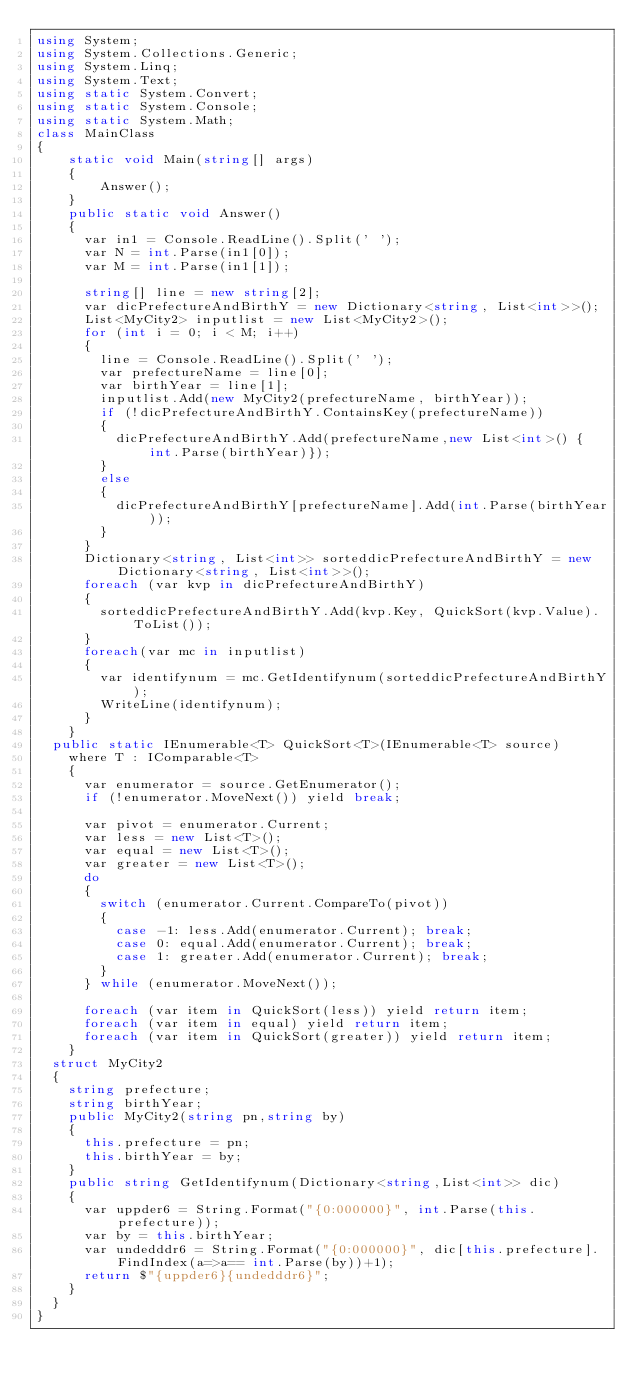Convert code to text. <code><loc_0><loc_0><loc_500><loc_500><_C#_>using System;
using System.Collections.Generic;
using System.Linq;
using System.Text;
using static System.Convert;
using static System.Console;
using static System.Math;
class MainClass
{
	static void Main(string[] args)
	{
		Answer();
	}
	public static void Answer()
	{
	  var in1 = Console.ReadLine().Split(' ');
      var N = int.Parse(in1[0]);
      var M = int.Parse(in1[1]);

      string[] line = new string[2];
      var dicPrefectureAndBirthY = new Dictionary<string, List<int>>();
      List<MyCity2> inputlist = new List<MyCity2>();
      for (int i = 0; i < M; i++)
      {
        line = Console.ReadLine().Split(' ');
        var prefectureName = line[0];
        var birthYear = line[1];
        inputlist.Add(new MyCity2(prefectureName, birthYear));
        if (!dicPrefectureAndBirthY.ContainsKey(prefectureName))
        {
          dicPrefectureAndBirthY.Add(prefectureName,new List<int>() { int.Parse(birthYear)});
        }
        else
        {
          dicPrefectureAndBirthY[prefectureName].Add(int.Parse(birthYear));
        }
      }
      Dictionary<string, List<int>> sorteddicPrefectureAndBirthY = new Dictionary<string, List<int>>();
      foreach (var kvp in dicPrefectureAndBirthY)
      {
        sorteddicPrefectureAndBirthY.Add(kvp.Key, QuickSort(kvp.Value).ToList());
      }
      foreach(var mc in inputlist)
      {
        var identifynum = mc.GetIdentifynum(sorteddicPrefectureAndBirthY);
        WriteLine(identifynum);
      }
	}
  public static IEnumerable<T> QuickSort<T>(IEnumerable<T> source)
    where T : IComparable<T>
    {
      var enumerator = source.GetEnumerator();
      if (!enumerator.MoveNext()) yield break;

      var pivot = enumerator.Current;
      var less = new List<T>();
      var equal = new List<T>();
      var greater = new List<T>();
      do
      {
        switch (enumerator.Current.CompareTo(pivot))
        {
          case -1: less.Add(enumerator.Current); break;
          case 0: equal.Add(enumerator.Current); break;
          case 1: greater.Add(enumerator.Current); break;
        }
      } while (enumerator.MoveNext());

      foreach (var item in QuickSort(less)) yield return item;
      foreach (var item in equal) yield return item;
      foreach (var item in QuickSort(greater)) yield return item;
    }
  struct MyCity2
  {
    string prefecture;
    string birthYear;
    public MyCity2(string pn,string by)
    {
      this.prefecture = pn;
      this.birthYear = by;
    }
    public string GetIdentifynum(Dictionary<string,List<int>> dic)
    {
      var uppder6 = String.Format("{0:000000}", int.Parse(this.prefecture));
      var by = this.birthYear;
      var undedddr6 = String.Format("{0:000000}", dic[this.prefecture].FindIndex(a=>a== int.Parse(by))+1);
      return $"{uppder6}{undedddr6}";
    }
  }
}</code> 